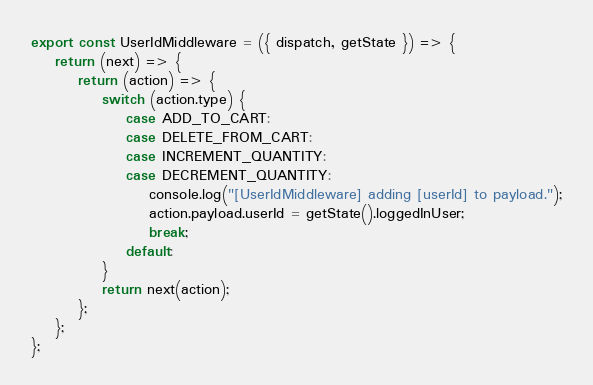Convert code to text. <code><loc_0><loc_0><loc_500><loc_500><_JavaScript_>
export const UserIdMiddleware = ({ dispatch, getState }) => {
	return (next) => {
		return (action) => {
			switch (action.type) {
				case ADD_TO_CART:
				case DELETE_FROM_CART:
				case INCREMENT_QUANTITY:
				case DECREMENT_QUANTITY:
					console.log("[UserIdMiddleware] adding [userId] to payload.");
					action.payload.userId = getState().loggedInUser;
					break;
				default:
			}
			return next(action);
		};
	};
};
</code> 